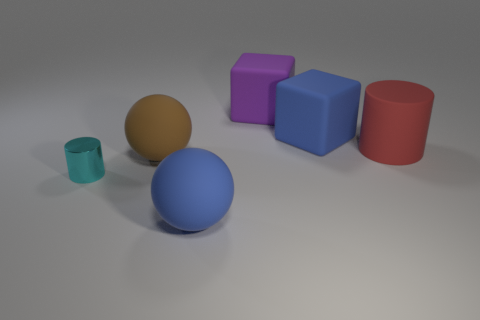Add 3 big purple rubber blocks. How many objects exist? 9 Subtract all balls. How many objects are left? 4 Subtract all cyan metal cylinders. Subtract all blue cubes. How many objects are left? 4 Add 4 big purple objects. How many big purple objects are left? 5 Add 4 big cyan metallic cylinders. How many big cyan metallic cylinders exist? 4 Subtract 0 purple cylinders. How many objects are left? 6 